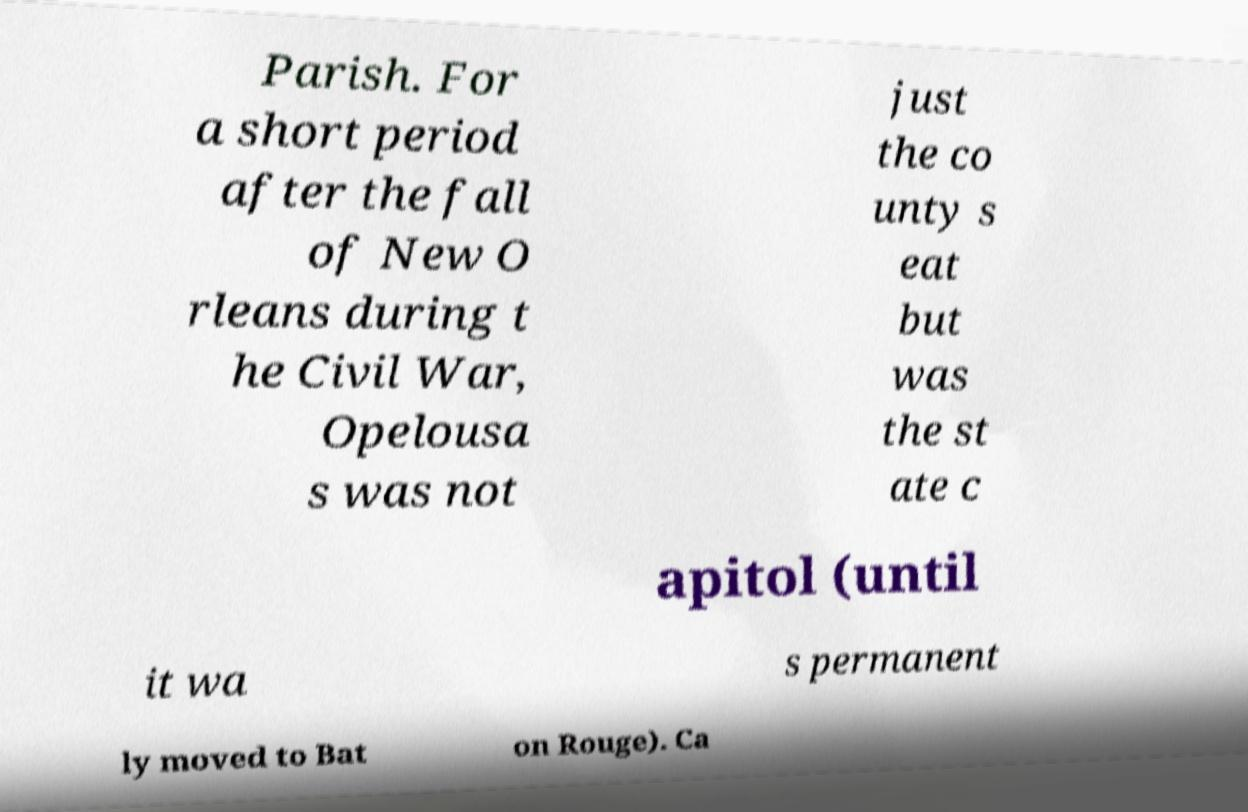I need the written content from this picture converted into text. Can you do that? Parish. For a short period after the fall of New O rleans during t he Civil War, Opelousa s was not just the co unty s eat but was the st ate c apitol (until it wa s permanent ly moved to Bat on Rouge). Ca 